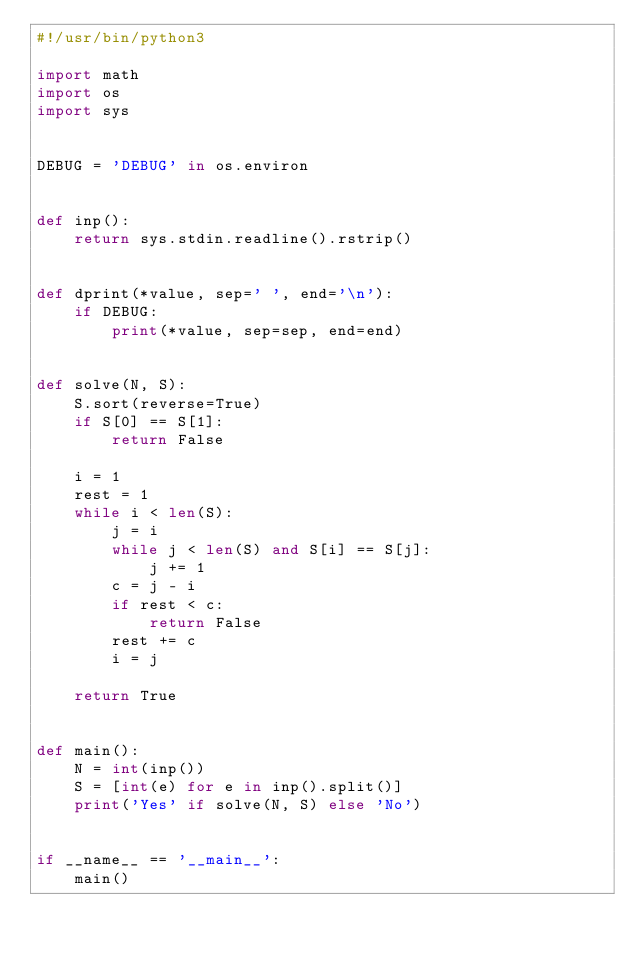<code> <loc_0><loc_0><loc_500><loc_500><_Python_>#!/usr/bin/python3

import math
import os
import sys


DEBUG = 'DEBUG' in os.environ


def inp():
    return sys.stdin.readline().rstrip()


def dprint(*value, sep=' ', end='\n'):
    if DEBUG:
        print(*value, sep=sep, end=end)


def solve(N, S):
    S.sort(reverse=True)
    if S[0] == S[1]:
        return False

    i = 1
    rest = 1
    while i < len(S):
        j = i
        while j < len(S) and S[i] == S[j]:
            j += 1
        c = j - i
        if rest < c:
            return False
        rest += c
        i = j

    return True


def main():
    N = int(inp())
    S = [int(e) for e in inp().split()]
    print('Yes' if solve(N, S) else 'No')


if __name__ == '__main__':
    main()
</code> 